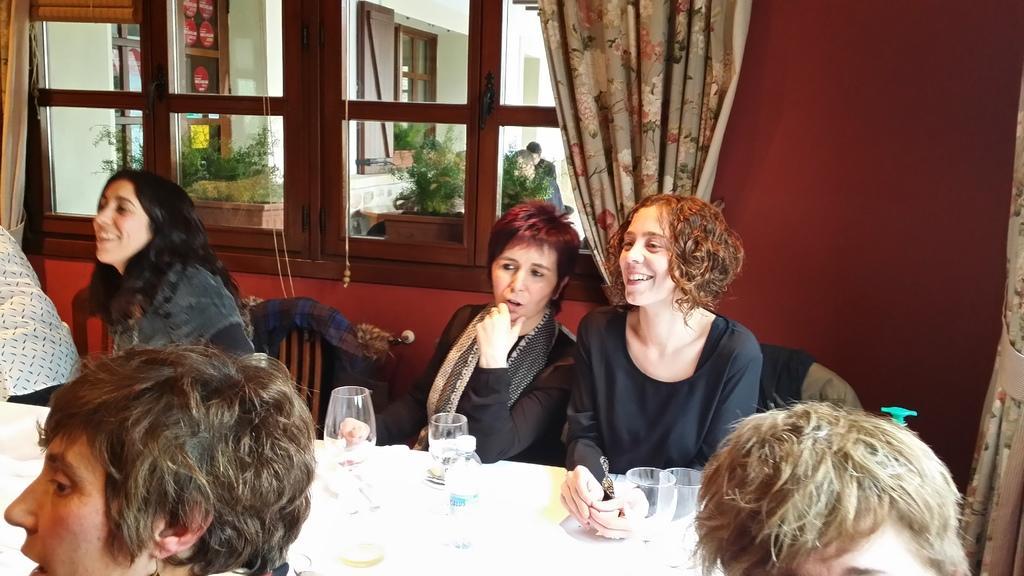Could you give a brief overview of what you see in this image? In this image, there are three persons wearing clothes and sitting in front of the table. This table contains glasses and bottles. There is a window at the top of the image contains curtains. There is a wall in the top right of the image. 